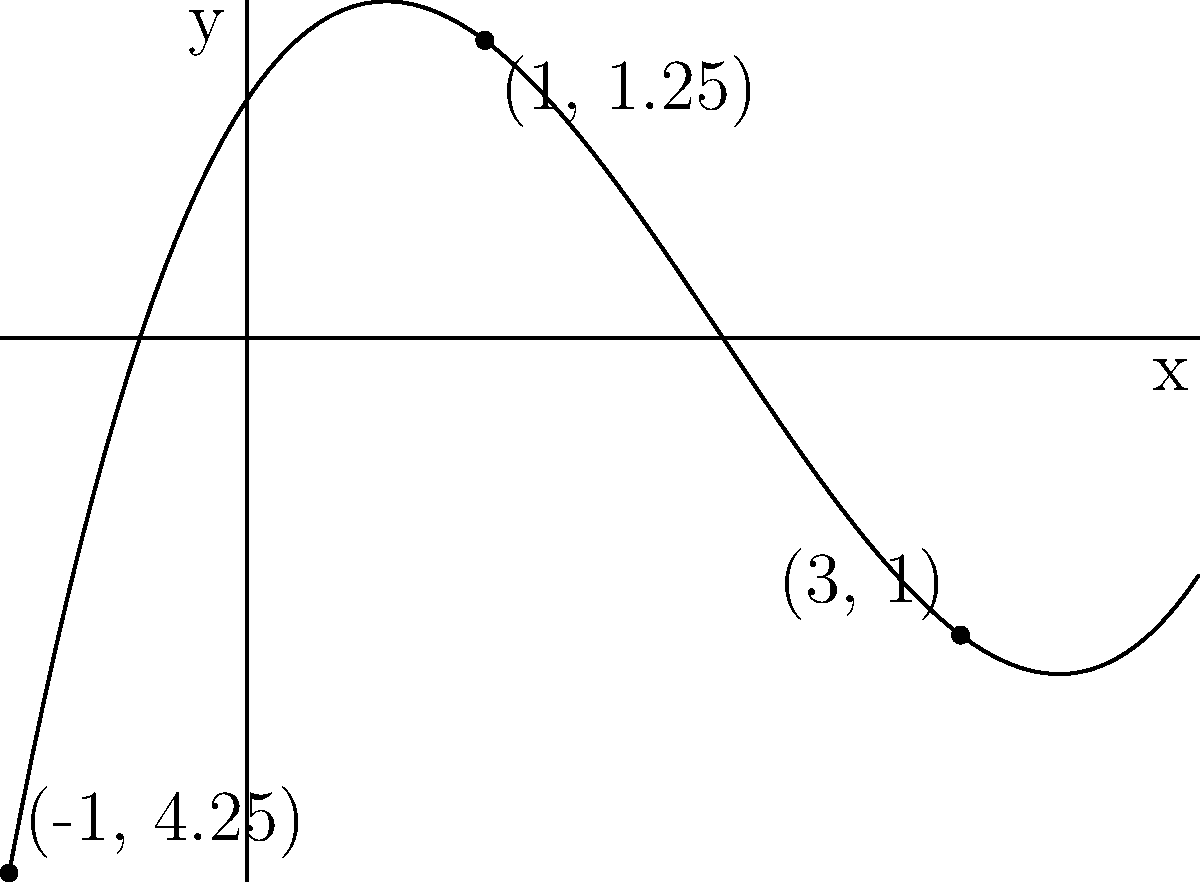Given the polynomial function $f(x) = 0.25x^3 - 1.5x^2 + 1.5x + 1$, and its critical points at $x = -1$, $x = 1$, and $x = 3$, sketch the graph of the function. What is the nature of each critical point (local maximum, local minimum, or neither)? To determine the nature of each critical point, we need to analyze the behavior of the function around these points:

1. Find the y-coordinates of the critical points:
   $f(-1) = 0.25(-1)^3 - 1.5(-1)^2 + 1.5(-1) + 1 = 4.25$
   $f(1) = 0.25(1)^3 - 1.5(1)^2 + 1.5(1) + 1 = 1.25$
   $f(3) = 0.25(3)^3 - 1.5(3)^2 + 1.5(3) + 1 = 1$

2. Analyze the function's behavior:
   a) At $x = -1$: The function decreases before -1 and increases after -1, so this is a local minimum.
   b) At $x = 1$: The function increases before 1 and decreases after 1, so this is a local maximum.
   c) At $x = 3$: The function decreases before 3 and increases after 3, so this is a local minimum.

3. Sketch the graph:
   - The function starts at a high y-value when x is very negative.
   - It decreases to a local minimum at (-1, 4.25).
   - It then increases to a local maximum at (1, 1.25).
   - It decreases again to a local minimum at (3, 1).
   - Finally, it increases as x becomes very large.

The graph in the asymptote code above illustrates these characteristics.
Answer: (-1, 4.25): Local minimum; (1, 1.25): Local maximum; (3, 1): Local minimum 